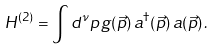<formula> <loc_0><loc_0><loc_500><loc_500>H ^ { ( 2 ) } = \int d ^ { \nu } p \, g ( \vec { p } ) \, a ^ { \dag } ( \vec { p } ) \, a ( \vec { p } ) \, .</formula> 